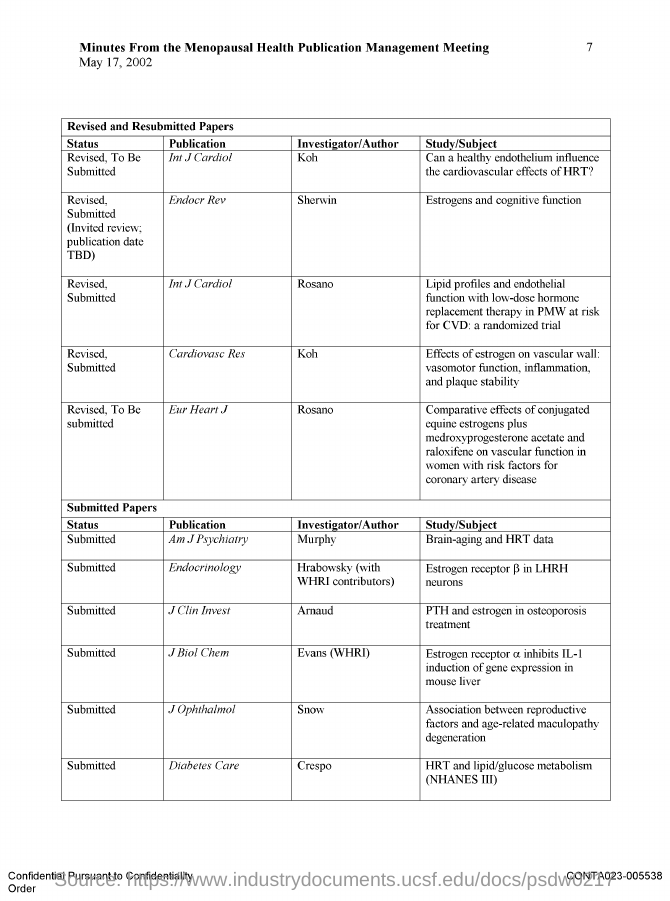Identify some key points in this picture. The investigator/author for the publication "J Clin Invest" is Arnaud. The name of the person who wrote the publication "Cardiovase Res" is unknown. The specific individual who is responsible for the publication titled "J Ophthalmol" is unknown. The investigator/author for the publication "Endocr Rev" is Sherwin. The investigator/author for the publication "Eur Heart J" is named Rosano. 